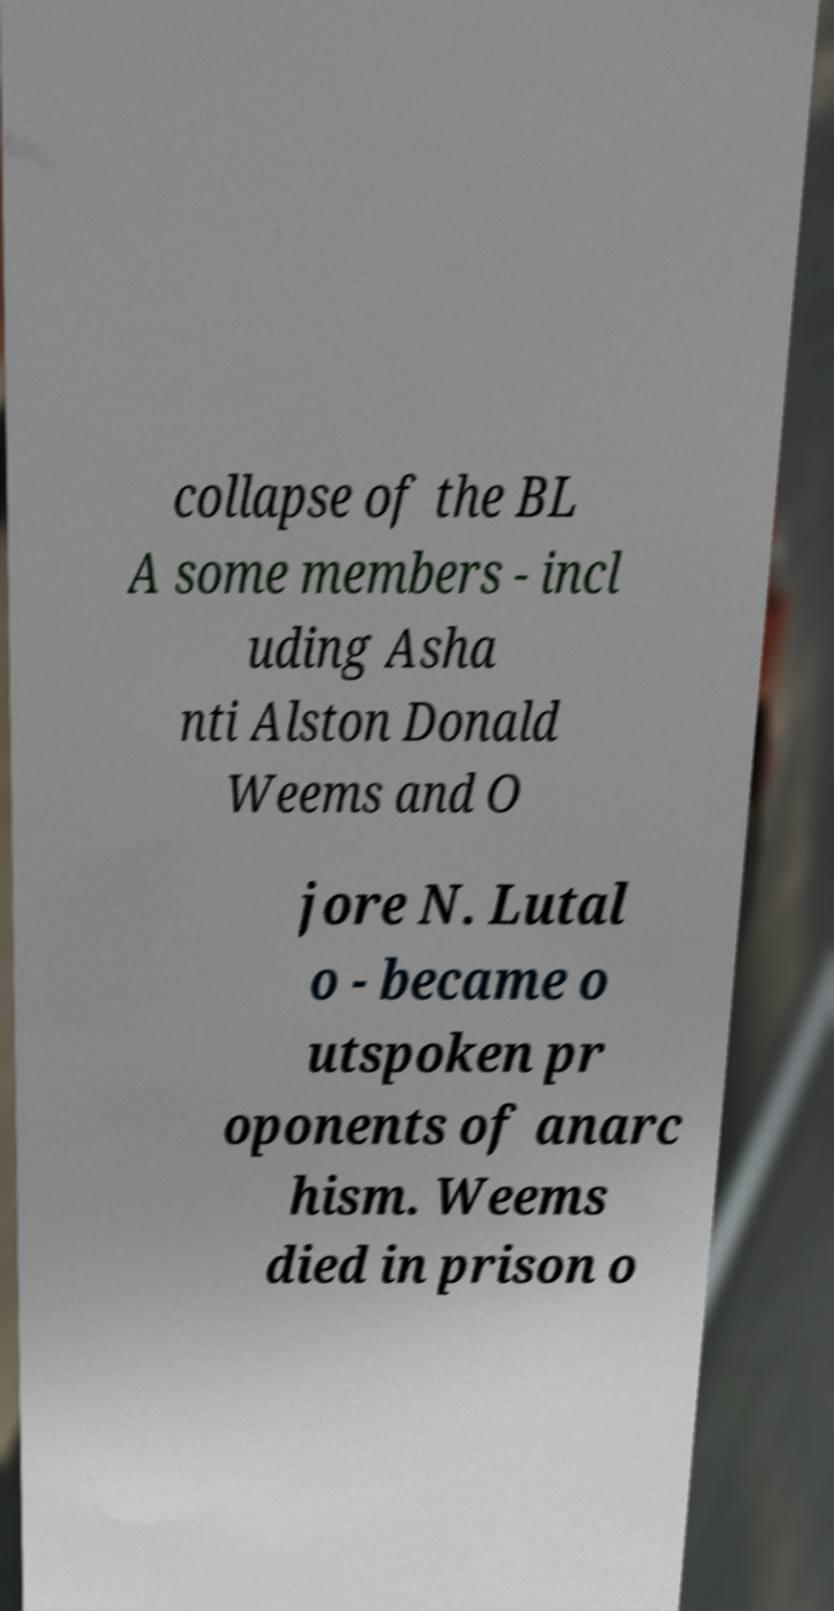Please identify and transcribe the text found in this image. collapse of the BL A some members - incl uding Asha nti Alston Donald Weems and O jore N. Lutal o - became o utspoken pr oponents of anarc hism. Weems died in prison o 